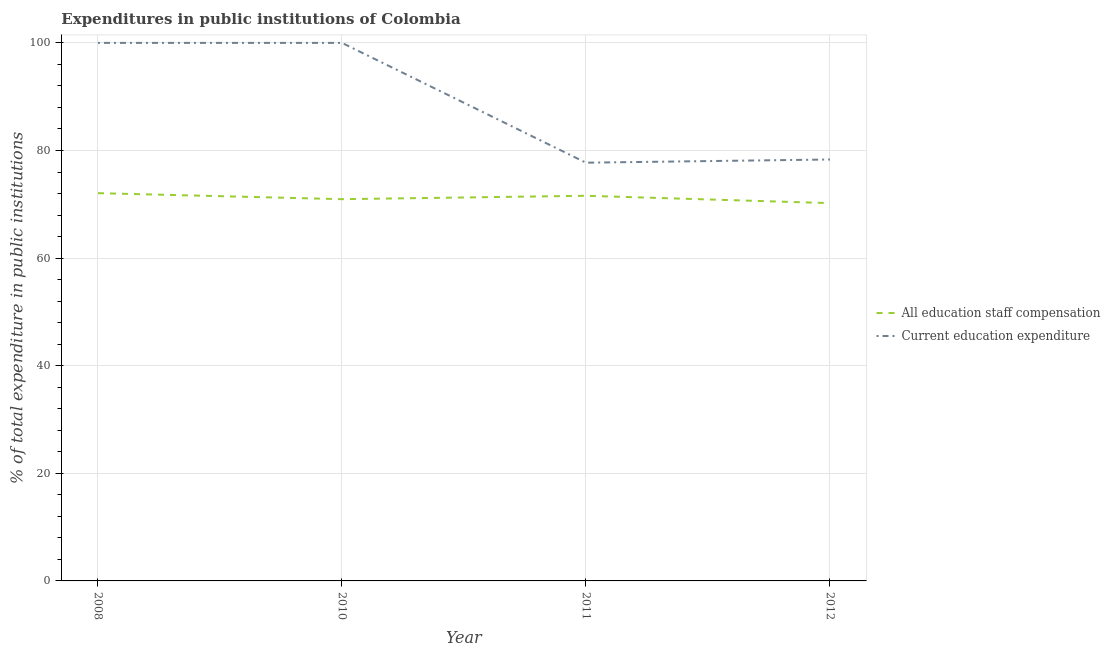Is the number of lines equal to the number of legend labels?
Provide a short and direct response. Yes. What is the expenditure in staff compensation in 2010?
Your answer should be very brief. 70.95. Across all years, what is the maximum expenditure in education?
Your answer should be compact. 100. Across all years, what is the minimum expenditure in staff compensation?
Offer a terse response. 70.22. In which year was the expenditure in education maximum?
Your answer should be compact. 2008. In which year was the expenditure in education minimum?
Make the answer very short. 2011. What is the total expenditure in education in the graph?
Give a very brief answer. 356.06. What is the difference between the expenditure in staff compensation in 2010 and that in 2011?
Your answer should be very brief. -0.63. What is the difference between the expenditure in staff compensation in 2012 and the expenditure in education in 2010?
Your answer should be very brief. -29.78. What is the average expenditure in education per year?
Provide a succinct answer. 89.02. In the year 2010, what is the difference between the expenditure in staff compensation and expenditure in education?
Give a very brief answer. -29.05. What is the ratio of the expenditure in staff compensation in 2008 to that in 2010?
Your response must be concise. 1.02. What is the difference between the highest and the second highest expenditure in staff compensation?
Your answer should be compact. 0.49. What is the difference between the highest and the lowest expenditure in staff compensation?
Offer a terse response. 1.85. Is the sum of the expenditure in staff compensation in 2008 and 2010 greater than the maximum expenditure in education across all years?
Provide a succinct answer. Yes. Does the expenditure in staff compensation monotonically increase over the years?
Your answer should be compact. No. Is the expenditure in education strictly greater than the expenditure in staff compensation over the years?
Make the answer very short. Yes. How many lines are there?
Offer a very short reply. 2. Does the graph contain any zero values?
Ensure brevity in your answer.  No. Does the graph contain grids?
Keep it short and to the point. Yes. How many legend labels are there?
Provide a short and direct response. 2. What is the title of the graph?
Ensure brevity in your answer.  Expenditures in public institutions of Colombia. What is the label or title of the Y-axis?
Keep it short and to the point. % of total expenditure in public institutions. What is the % of total expenditure in public institutions in All education staff compensation in 2008?
Your response must be concise. 72.07. What is the % of total expenditure in public institutions in All education staff compensation in 2010?
Your response must be concise. 70.95. What is the % of total expenditure in public institutions of Current education expenditure in 2010?
Make the answer very short. 100. What is the % of total expenditure in public institutions of All education staff compensation in 2011?
Offer a very short reply. 71.58. What is the % of total expenditure in public institutions of Current education expenditure in 2011?
Offer a terse response. 77.73. What is the % of total expenditure in public institutions of All education staff compensation in 2012?
Your response must be concise. 70.22. What is the % of total expenditure in public institutions of Current education expenditure in 2012?
Make the answer very short. 78.33. Across all years, what is the maximum % of total expenditure in public institutions in All education staff compensation?
Keep it short and to the point. 72.07. Across all years, what is the minimum % of total expenditure in public institutions of All education staff compensation?
Your answer should be compact. 70.22. Across all years, what is the minimum % of total expenditure in public institutions in Current education expenditure?
Provide a succinct answer. 77.73. What is the total % of total expenditure in public institutions of All education staff compensation in the graph?
Your answer should be very brief. 284.83. What is the total % of total expenditure in public institutions in Current education expenditure in the graph?
Keep it short and to the point. 356.06. What is the difference between the % of total expenditure in public institutions in All education staff compensation in 2008 and that in 2010?
Ensure brevity in your answer.  1.12. What is the difference between the % of total expenditure in public institutions of Current education expenditure in 2008 and that in 2010?
Your answer should be very brief. 0. What is the difference between the % of total expenditure in public institutions of All education staff compensation in 2008 and that in 2011?
Provide a short and direct response. 0.49. What is the difference between the % of total expenditure in public institutions in Current education expenditure in 2008 and that in 2011?
Your answer should be compact. 22.27. What is the difference between the % of total expenditure in public institutions in All education staff compensation in 2008 and that in 2012?
Give a very brief answer. 1.85. What is the difference between the % of total expenditure in public institutions of Current education expenditure in 2008 and that in 2012?
Your response must be concise. 21.67. What is the difference between the % of total expenditure in public institutions of All education staff compensation in 2010 and that in 2011?
Your answer should be compact. -0.63. What is the difference between the % of total expenditure in public institutions in Current education expenditure in 2010 and that in 2011?
Give a very brief answer. 22.27. What is the difference between the % of total expenditure in public institutions of All education staff compensation in 2010 and that in 2012?
Keep it short and to the point. 0.73. What is the difference between the % of total expenditure in public institutions of Current education expenditure in 2010 and that in 2012?
Offer a terse response. 21.67. What is the difference between the % of total expenditure in public institutions of All education staff compensation in 2011 and that in 2012?
Ensure brevity in your answer.  1.36. What is the difference between the % of total expenditure in public institutions in Current education expenditure in 2011 and that in 2012?
Provide a succinct answer. -0.6. What is the difference between the % of total expenditure in public institutions of All education staff compensation in 2008 and the % of total expenditure in public institutions of Current education expenditure in 2010?
Your answer should be very brief. -27.93. What is the difference between the % of total expenditure in public institutions in All education staff compensation in 2008 and the % of total expenditure in public institutions in Current education expenditure in 2011?
Ensure brevity in your answer.  -5.66. What is the difference between the % of total expenditure in public institutions of All education staff compensation in 2008 and the % of total expenditure in public institutions of Current education expenditure in 2012?
Your answer should be very brief. -6.26. What is the difference between the % of total expenditure in public institutions in All education staff compensation in 2010 and the % of total expenditure in public institutions in Current education expenditure in 2011?
Make the answer very short. -6.78. What is the difference between the % of total expenditure in public institutions in All education staff compensation in 2010 and the % of total expenditure in public institutions in Current education expenditure in 2012?
Give a very brief answer. -7.38. What is the difference between the % of total expenditure in public institutions of All education staff compensation in 2011 and the % of total expenditure in public institutions of Current education expenditure in 2012?
Provide a short and direct response. -6.75. What is the average % of total expenditure in public institutions of All education staff compensation per year?
Provide a succinct answer. 71.21. What is the average % of total expenditure in public institutions of Current education expenditure per year?
Offer a terse response. 89.02. In the year 2008, what is the difference between the % of total expenditure in public institutions of All education staff compensation and % of total expenditure in public institutions of Current education expenditure?
Offer a very short reply. -27.93. In the year 2010, what is the difference between the % of total expenditure in public institutions in All education staff compensation and % of total expenditure in public institutions in Current education expenditure?
Provide a short and direct response. -29.05. In the year 2011, what is the difference between the % of total expenditure in public institutions in All education staff compensation and % of total expenditure in public institutions in Current education expenditure?
Provide a succinct answer. -6.15. In the year 2012, what is the difference between the % of total expenditure in public institutions in All education staff compensation and % of total expenditure in public institutions in Current education expenditure?
Provide a short and direct response. -8.11. What is the ratio of the % of total expenditure in public institutions in All education staff compensation in 2008 to that in 2010?
Your answer should be very brief. 1.02. What is the ratio of the % of total expenditure in public institutions of All education staff compensation in 2008 to that in 2011?
Your answer should be very brief. 1.01. What is the ratio of the % of total expenditure in public institutions in Current education expenditure in 2008 to that in 2011?
Your response must be concise. 1.29. What is the ratio of the % of total expenditure in public institutions of All education staff compensation in 2008 to that in 2012?
Your answer should be compact. 1.03. What is the ratio of the % of total expenditure in public institutions of Current education expenditure in 2008 to that in 2012?
Offer a terse response. 1.28. What is the ratio of the % of total expenditure in public institutions of Current education expenditure in 2010 to that in 2011?
Your response must be concise. 1.29. What is the ratio of the % of total expenditure in public institutions in All education staff compensation in 2010 to that in 2012?
Give a very brief answer. 1.01. What is the ratio of the % of total expenditure in public institutions of Current education expenditure in 2010 to that in 2012?
Keep it short and to the point. 1.28. What is the ratio of the % of total expenditure in public institutions of All education staff compensation in 2011 to that in 2012?
Offer a terse response. 1.02. What is the difference between the highest and the second highest % of total expenditure in public institutions in All education staff compensation?
Make the answer very short. 0.49. What is the difference between the highest and the second highest % of total expenditure in public institutions in Current education expenditure?
Provide a succinct answer. 0. What is the difference between the highest and the lowest % of total expenditure in public institutions of All education staff compensation?
Your answer should be very brief. 1.85. What is the difference between the highest and the lowest % of total expenditure in public institutions of Current education expenditure?
Provide a short and direct response. 22.27. 